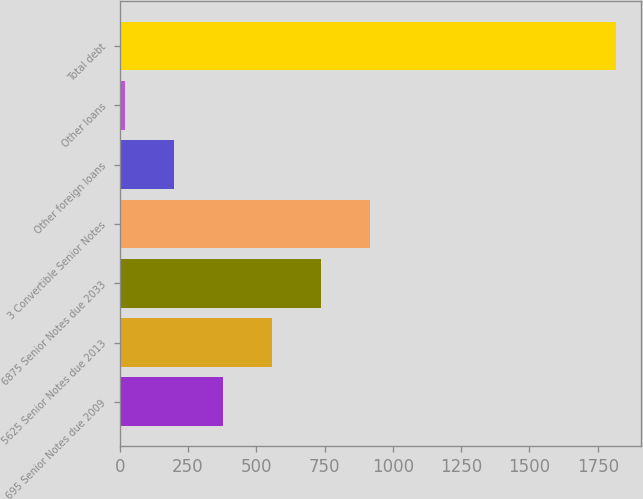<chart> <loc_0><loc_0><loc_500><loc_500><bar_chart><fcel>695 Senior Notes due 2009<fcel>5625 Senior Notes due 2013<fcel>6875 Senior Notes due 2033<fcel>3 Convertible Senior Notes<fcel>Other foreign loans<fcel>Other loans<fcel>Total debt<nl><fcel>377.94<fcel>557.91<fcel>737.88<fcel>917.85<fcel>197.97<fcel>18<fcel>1817.7<nl></chart> 